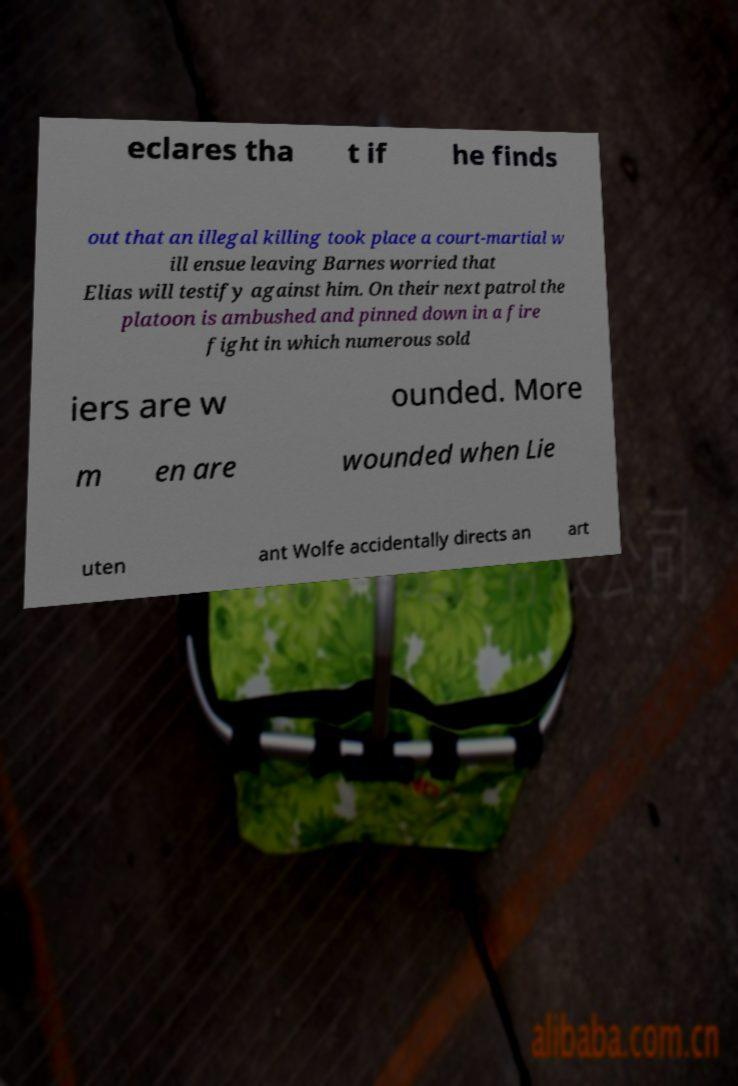For documentation purposes, I need the text within this image transcribed. Could you provide that? eclares tha t if he finds out that an illegal killing took place a court-martial w ill ensue leaving Barnes worried that Elias will testify against him. On their next patrol the platoon is ambushed and pinned down in a fire fight in which numerous sold iers are w ounded. More m en are wounded when Lie uten ant Wolfe accidentally directs an art 